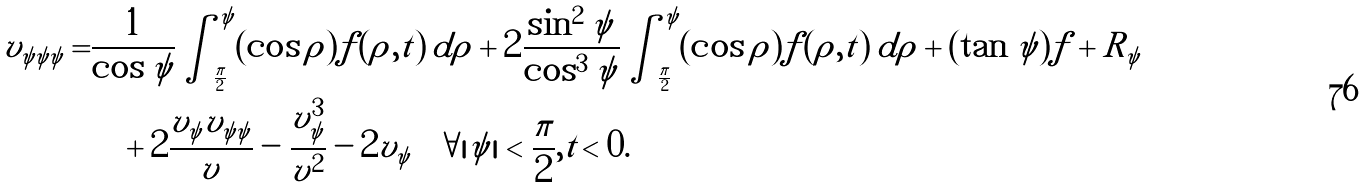<formula> <loc_0><loc_0><loc_500><loc_500>v _ { \psi \psi \psi } = & \frac { 1 } { \cos \psi } \int _ { \frac { \pi } { 2 } } ^ { \psi } ( \cos \rho ) f ( \rho , t ) \, d \rho + 2 \frac { \sin ^ { 2 } \psi } { \cos ^ { 3 } \psi } \int _ { \frac { \pi } { 2 } } ^ { \psi } ( \cos \rho ) f ( \rho , t ) \, d \rho + ( \tan \psi ) f + R _ { \psi } \\ & \quad + 2 \frac { v _ { \psi } v _ { \psi \psi } } { v } - \frac { v _ { \psi } ^ { 3 } } { v ^ { 2 } } - 2 v _ { \psi } \quad \forall | \psi | < \frac { \pi } { 2 } , t < 0 .</formula> 